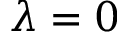Convert formula to latex. <formula><loc_0><loc_0><loc_500><loc_500>\lambda = 0</formula> 